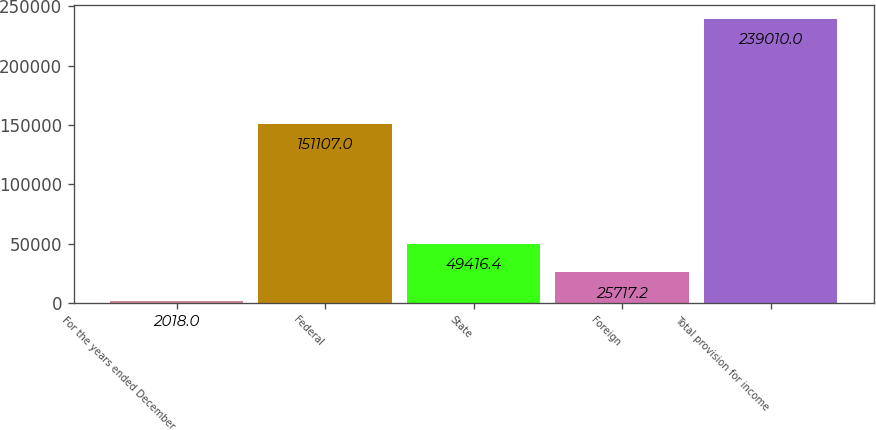<chart> <loc_0><loc_0><loc_500><loc_500><bar_chart><fcel>For the years ended December<fcel>Federal<fcel>State<fcel>Foreign<fcel>Total provision for income<nl><fcel>2018<fcel>151107<fcel>49416.4<fcel>25717.2<fcel>239010<nl></chart> 